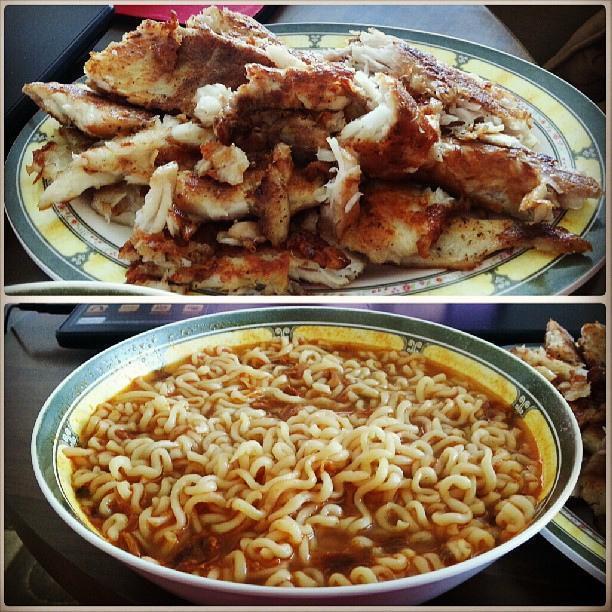How many dining tables can you see?
Give a very brief answer. 2. How many people are to the left of the frisbe player with the green shirt?
Give a very brief answer. 0. 